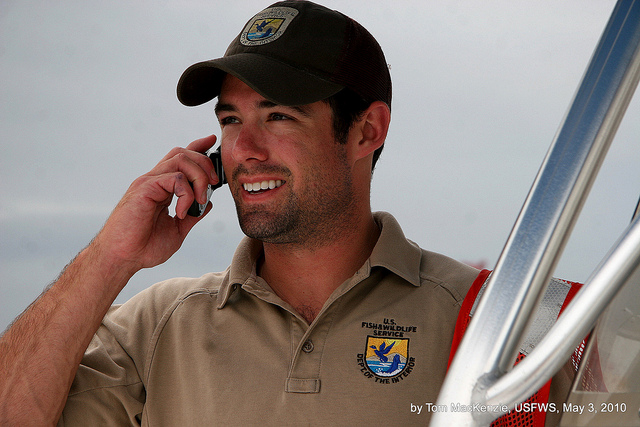Identify the text contained in this image. by TOHT MacKenzie USFWS May 2010 3 WITERIOR TME OF DEPT SERVICE FISH&amp;WILDLIFE U.S. 